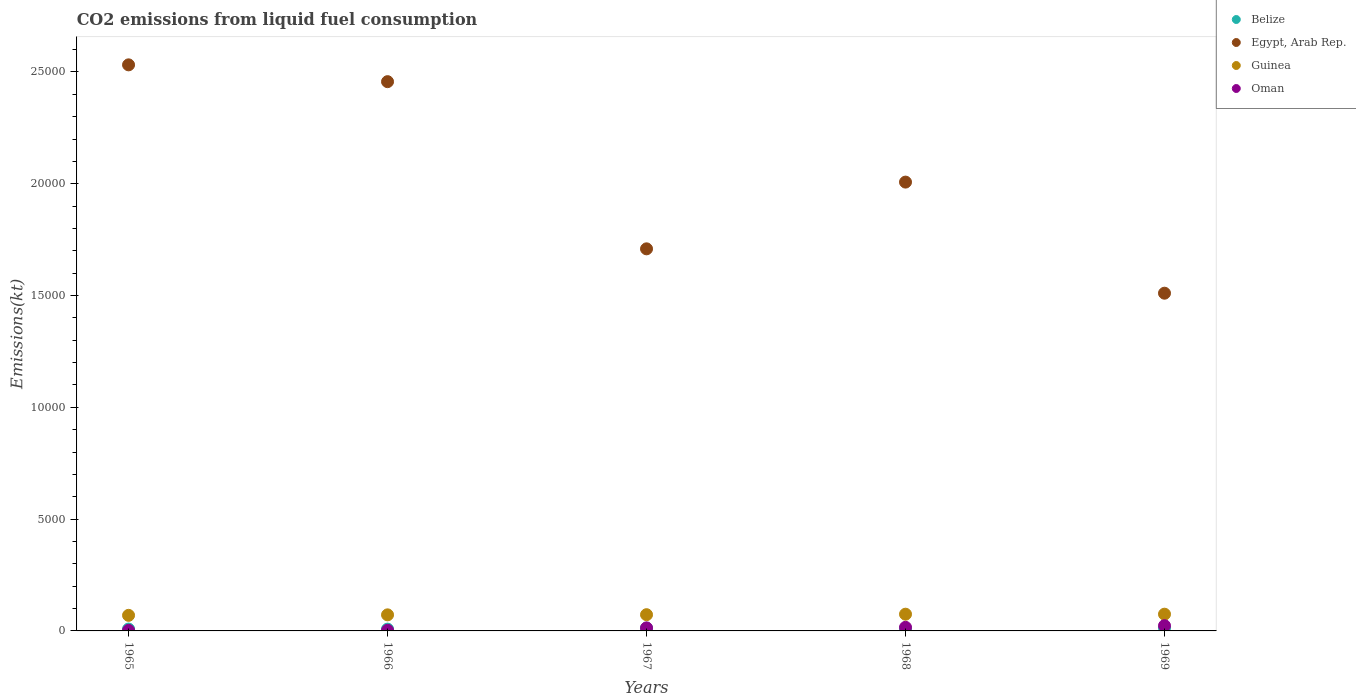Is the number of dotlines equal to the number of legend labels?
Keep it short and to the point. Yes. What is the amount of CO2 emitted in Belize in 1966?
Keep it short and to the point. 80.67. Across all years, what is the maximum amount of CO2 emitted in Oman?
Ensure brevity in your answer.  234.69. Across all years, what is the minimum amount of CO2 emitted in Guinea?
Make the answer very short. 696.73. In which year was the amount of CO2 emitted in Belize maximum?
Keep it short and to the point. 1969. In which year was the amount of CO2 emitted in Oman minimum?
Make the answer very short. 1965. What is the total amount of CO2 emitted in Oman in the graph?
Give a very brief answer. 586.72. What is the difference between the amount of CO2 emitted in Egypt, Arab Rep. in 1966 and that in 1969?
Provide a short and direct response. 9460.86. What is the difference between the amount of CO2 emitted in Belize in 1966 and the amount of CO2 emitted in Guinea in 1969?
Ensure brevity in your answer.  -667.39. What is the average amount of CO2 emitted in Guinea per year?
Provide a succinct answer. 727.53. In the year 1966, what is the difference between the amount of CO2 emitted in Guinea and amount of CO2 emitted in Belize?
Provide a short and direct response. 638.06. What is the ratio of the amount of CO2 emitted in Belize in 1967 to that in 1968?
Keep it short and to the point. 1.18. Is the difference between the amount of CO2 emitted in Guinea in 1967 and 1969 greater than the difference between the amount of CO2 emitted in Belize in 1967 and 1969?
Give a very brief answer. No. What is the difference between the highest and the second highest amount of CO2 emitted in Belize?
Ensure brevity in your answer.  14.67. What is the difference between the highest and the lowest amount of CO2 emitted in Oman?
Your answer should be very brief. 209.02. In how many years, is the amount of CO2 emitted in Oman greater than the average amount of CO2 emitted in Oman taken over all years?
Your answer should be compact. 3. Is it the case that in every year, the sum of the amount of CO2 emitted in Oman and amount of CO2 emitted in Guinea  is greater than the sum of amount of CO2 emitted in Egypt, Arab Rep. and amount of CO2 emitted in Belize?
Provide a short and direct response. Yes. Is it the case that in every year, the sum of the amount of CO2 emitted in Oman and amount of CO2 emitted in Egypt, Arab Rep.  is greater than the amount of CO2 emitted in Guinea?
Offer a very short reply. Yes. Does the amount of CO2 emitted in Egypt, Arab Rep. monotonically increase over the years?
Your answer should be compact. No. Is the amount of CO2 emitted in Belize strictly greater than the amount of CO2 emitted in Egypt, Arab Rep. over the years?
Offer a terse response. No. Is the amount of CO2 emitted in Belize strictly less than the amount of CO2 emitted in Egypt, Arab Rep. over the years?
Make the answer very short. Yes. How many dotlines are there?
Offer a terse response. 4. How many years are there in the graph?
Make the answer very short. 5. Are the values on the major ticks of Y-axis written in scientific E-notation?
Make the answer very short. No. Does the graph contain any zero values?
Keep it short and to the point. No. Does the graph contain grids?
Provide a short and direct response. No. Where does the legend appear in the graph?
Your answer should be very brief. Top right. How are the legend labels stacked?
Your answer should be compact. Vertical. What is the title of the graph?
Provide a short and direct response. CO2 emissions from liquid fuel consumption. What is the label or title of the X-axis?
Provide a succinct answer. Years. What is the label or title of the Y-axis?
Offer a very short reply. Emissions(kt). What is the Emissions(kt) of Belize in 1965?
Make the answer very short. 84.34. What is the Emissions(kt) of Egypt, Arab Rep. in 1965?
Make the answer very short. 2.53e+04. What is the Emissions(kt) in Guinea in 1965?
Your answer should be very brief. 696.73. What is the Emissions(kt) of Oman in 1965?
Make the answer very short. 25.67. What is the Emissions(kt) of Belize in 1966?
Your answer should be compact. 80.67. What is the Emissions(kt) of Egypt, Arab Rep. in 1966?
Ensure brevity in your answer.  2.46e+04. What is the Emissions(kt) in Guinea in 1966?
Give a very brief answer. 718.73. What is the Emissions(kt) of Oman in 1966?
Provide a succinct answer. 29.34. What is the Emissions(kt) in Belize in 1967?
Give a very brief answer. 121.01. What is the Emissions(kt) in Egypt, Arab Rep. in 1967?
Provide a short and direct response. 1.71e+04. What is the Emissions(kt) in Guinea in 1967?
Provide a succinct answer. 726.07. What is the Emissions(kt) of Oman in 1967?
Your answer should be compact. 135.68. What is the Emissions(kt) of Belize in 1968?
Offer a terse response. 102.68. What is the Emissions(kt) of Egypt, Arab Rep. in 1968?
Offer a terse response. 2.01e+04. What is the Emissions(kt) in Guinea in 1968?
Your response must be concise. 748.07. What is the Emissions(kt) in Oman in 1968?
Offer a terse response. 161.35. What is the Emissions(kt) of Belize in 1969?
Ensure brevity in your answer.  135.68. What is the Emissions(kt) in Egypt, Arab Rep. in 1969?
Your answer should be compact. 1.51e+04. What is the Emissions(kt) in Guinea in 1969?
Provide a short and direct response. 748.07. What is the Emissions(kt) of Oman in 1969?
Your answer should be very brief. 234.69. Across all years, what is the maximum Emissions(kt) of Belize?
Your answer should be very brief. 135.68. Across all years, what is the maximum Emissions(kt) in Egypt, Arab Rep.?
Offer a very short reply. 2.53e+04. Across all years, what is the maximum Emissions(kt) in Guinea?
Ensure brevity in your answer.  748.07. Across all years, what is the maximum Emissions(kt) of Oman?
Ensure brevity in your answer.  234.69. Across all years, what is the minimum Emissions(kt) in Belize?
Your answer should be very brief. 80.67. Across all years, what is the minimum Emissions(kt) in Egypt, Arab Rep.?
Your answer should be very brief. 1.51e+04. Across all years, what is the minimum Emissions(kt) of Guinea?
Ensure brevity in your answer.  696.73. Across all years, what is the minimum Emissions(kt) of Oman?
Give a very brief answer. 25.67. What is the total Emissions(kt) of Belize in the graph?
Offer a terse response. 524.38. What is the total Emissions(kt) in Egypt, Arab Rep. in the graph?
Offer a very short reply. 1.02e+05. What is the total Emissions(kt) in Guinea in the graph?
Your response must be concise. 3637.66. What is the total Emissions(kt) in Oman in the graph?
Your answer should be very brief. 586.72. What is the difference between the Emissions(kt) of Belize in 1965 and that in 1966?
Provide a short and direct response. 3.67. What is the difference between the Emissions(kt) of Egypt, Arab Rep. in 1965 and that in 1966?
Keep it short and to the point. 751.74. What is the difference between the Emissions(kt) of Guinea in 1965 and that in 1966?
Give a very brief answer. -22. What is the difference between the Emissions(kt) of Oman in 1965 and that in 1966?
Ensure brevity in your answer.  -3.67. What is the difference between the Emissions(kt) of Belize in 1965 and that in 1967?
Your response must be concise. -36.67. What is the difference between the Emissions(kt) in Egypt, Arab Rep. in 1965 and that in 1967?
Your response must be concise. 8228.75. What is the difference between the Emissions(kt) in Guinea in 1965 and that in 1967?
Provide a succinct answer. -29.34. What is the difference between the Emissions(kt) of Oman in 1965 and that in 1967?
Give a very brief answer. -110.01. What is the difference between the Emissions(kt) in Belize in 1965 and that in 1968?
Give a very brief answer. -18.34. What is the difference between the Emissions(kt) in Egypt, Arab Rep. in 1965 and that in 1968?
Provide a short and direct response. 5243.81. What is the difference between the Emissions(kt) of Guinea in 1965 and that in 1968?
Ensure brevity in your answer.  -51.34. What is the difference between the Emissions(kt) in Oman in 1965 and that in 1968?
Give a very brief answer. -135.68. What is the difference between the Emissions(kt) of Belize in 1965 and that in 1969?
Offer a very short reply. -51.34. What is the difference between the Emissions(kt) in Egypt, Arab Rep. in 1965 and that in 1969?
Your response must be concise. 1.02e+04. What is the difference between the Emissions(kt) in Guinea in 1965 and that in 1969?
Keep it short and to the point. -51.34. What is the difference between the Emissions(kt) of Oman in 1965 and that in 1969?
Offer a very short reply. -209.02. What is the difference between the Emissions(kt) of Belize in 1966 and that in 1967?
Your answer should be very brief. -40.34. What is the difference between the Emissions(kt) of Egypt, Arab Rep. in 1966 and that in 1967?
Offer a very short reply. 7477.01. What is the difference between the Emissions(kt) in Guinea in 1966 and that in 1967?
Give a very brief answer. -7.33. What is the difference between the Emissions(kt) in Oman in 1966 and that in 1967?
Offer a terse response. -106.34. What is the difference between the Emissions(kt) of Belize in 1966 and that in 1968?
Make the answer very short. -22. What is the difference between the Emissions(kt) in Egypt, Arab Rep. in 1966 and that in 1968?
Keep it short and to the point. 4492.07. What is the difference between the Emissions(kt) of Guinea in 1966 and that in 1968?
Provide a succinct answer. -29.34. What is the difference between the Emissions(kt) of Oman in 1966 and that in 1968?
Provide a succinct answer. -132.01. What is the difference between the Emissions(kt) of Belize in 1966 and that in 1969?
Offer a terse response. -55.01. What is the difference between the Emissions(kt) of Egypt, Arab Rep. in 1966 and that in 1969?
Your response must be concise. 9460.86. What is the difference between the Emissions(kt) in Guinea in 1966 and that in 1969?
Give a very brief answer. -29.34. What is the difference between the Emissions(kt) of Oman in 1966 and that in 1969?
Give a very brief answer. -205.35. What is the difference between the Emissions(kt) in Belize in 1967 and that in 1968?
Offer a very short reply. 18.34. What is the difference between the Emissions(kt) of Egypt, Arab Rep. in 1967 and that in 1968?
Keep it short and to the point. -2984.94. What is the difference between the Emissions(kt) in Guinea in 1967 and that in 1968?
Your response must be concise. -22. What is the difference between the Emissions(kt) in Oman in 1967 and that in 1968?
Give a very brief answer. -25.67. What is the difference between the Emissions(kt) in Belize in 1967 and that in 1969?
Provide a succinct answer. -14.67. What is the difference between the Emissions(kt) of Egypt, Arab Rep. in 1967 and that in 1969?
Offer a terse response. 1983.85. What is the difference between the Emissions(kt) in Guinea in 1967 and that in 1969?
Your answer should be compact. -22. What is the difference between the Emissions(kt) of Oman in 1967 and that in 1969?
Give a very brief answer. -99.01. What is the difference between the Emissions(kt) in Belize in 1968 and that in 1969?
Give a very brief answer. -33. What is the difference between the Emissions(kt) in Egypt, Arab Rep. in 1968 and that in 1969?
Give a very brief answer. 4968.78. What is the difference between the Emissions(kt) of Oman in 1968 and that in 1969?
Your answer should be compact. -73.34. What is the difference between the Emissions(kt) in Belize in 1965 and the Emissions(kt) in Egypt, Arab Rep. in 1966?
Your answer should be compact. -2.45e+04. What is the difference between the Emissions(kt) of Belize in 1965 and the Emissions(kt) of Guinea in 1966?
Keep it short and to the point. -634.39. What is the difference between the Emissions(kt) of Belize in 1965 and the Emissions(kt) of Oman in 1966?
Offer a terse response. 55.01. What is the difference between the Emissions(kt) of Egypt, Arab Rep. in 1965 and the Emissions(kt) of Guinea in 1966?
Your response must be concise. 2.46e+04. What is the difference between the Emissions(kt) of Egypt, Arab Rep. in 1965 and the Emissions(kt) of Oman in 1966?
Ensure brevity in your answer.  2.53e+04. What is the difference between the Emissions(kt) in Guinea in 1965 and the Emissions(kt) in Oman in 1966?
Offer a terse response. 667.39. What is the difference between the Emissions(kt) in Belize in 1965 and the Emissions(kt) in Egypt, Arab Rep. in 1967?
Your answer should be very brief. -1.70e+04. What is the difference between the Emissions(kt) in Belize in 1965 and the Emissions(kt) in Guinea in 1967?
Give a very brief answer. -641.73. What is the difference between the Emissions(kt) in Belize in 1965 and the Emissions(kt) in Oman in 1967?
Ensure brevity in your answer.  -51.34. What is the difference between the Emissions(kt) in Egypt, Arab Rep. in 1965 and the Emissions(kt) in Guinea in 1967?
Offer a terse response. 2.46e+04. What is the difference between the Emissions(kt) of Egypt, Arab Rep. in 1965 and the Emissions(kt) of Oman in 1967?
Make the answer very short. 2.52e+04. What is the difference between the Emissions(kt) of Guinea in 1965 and the Emissions(kt) of Oman in 1967?
Give a very brief answer. 561.05. What is the difference between the Emissions(kt) in Belize in 1965 and the Emissions(kt) in Egypt, Arab Rep. in 1968?
Provide a succinct answer. -2.00e+04. What is the difference between the Emissions(kt) of Belize in 1965 and the Emissions(kt) of Guinea in 1968?
Make the answer very short. -663.73. What is the difference between the Emissions(kt) in Belize in 1965 and the Emissions(kt) in Oman in 1968?
Provide a short and direct response. -77.01. What is the difference between the Emissions(kt) of Egypt, Arab Rep. in 1965 and the Emissions(kt) of Guinea in 1968?
Offer a very short reply. 2.46e+04. What is the difference between the Emissions(kt) in Egypt, Arab Rep. in 1965 and the Emissions(kt) in Oman in 1968?
Your answer should be compact. 2.52e+04. What is the difference between the Emissions(kt) in Guinea in 1965 and the Emissions(kt) in Oman in 1968?
Provide a short and direct response. 535.38. What is the difference between the Emissions(kt) of Belize in 1965 and the Emissions(kt) of Egypt, Arab Rep. in 1969?
Provide a short and direct response. -1.50e+04. What is the difference between the Emissions(kt) in Belize in 1965 and the Emissions(kt) in Guinea in 1969?
Offer a very short reply. -663.73. What is the difference between the Emissions(kt) in Belize in 1965 and the Emissions(kt) in Oman in 1969?
Make the answer very short. -150.35. What is the difference between the Emissions(kt) in Egypt, Arab Rep. in 1965 and the Emissions(kt) in Guinea in 1969?
Provide a succinct answer. 2.46e+04. What is the difference between the Emissions(kt) in Egypt, Arab Rep. in 1965 and the Emissions(kt) in Oman in 1969?
Provide a short and direct response. 2.51e+04. What is the difference between the Emissions(kt) in Guinea in 1965 and the Emissions(kt) in Oman in 1969?
Your answer should be very brief. 462.04. What is the difference between the Emissions(kt) of Belize in 1966 and the Emissions(kt) of Egypt, Arab Rep. in 1967?
Give a very brief answer. -1.70e+04. What is the difference between the Emissions(kt) of Belize in 1966 and the Emissions(kt) of Guinea in 1967?
Keep it short and to the point. -645.39. What is the difference between the Emissions(kt) in Belize in 1966 and the Emissions(kt) in Oman in 1967?
Your answer should be very brief. -55.01. What is the difference between the Emissions(kt) of Egypt, Arab Rep. in 1966 and the Emissions(kt) of Guinea in 1967?
Your answer should be compact. 2.38e+04. What is the difference between the Emissions(kt) in Egypt, Arab Rep. in 1966 and the Emissions(kt) in Oman in 1967?
Provide a succinct answer. 2.44e+04. What is the difference between the Emissions(kt) of Guinea in 1966 and the Emissions(kt) of Oman in 1967?
Offer a terse response. 583.05. What is the difference between the Emissions(kt) in Belize in 1966 and the Emissions(kt) in Egypt, Arab Rep. in 1968?
Offer a very short reply. -2.00e+04. What is the difference between the Emissions(kt) of Belize in 1966 and the Emissions(kt) of Guinea in 1968?
Give a very brief answer. -667.39. What is the difference between the Emissions(kt) of Belize in 1966 and the Emissions(kt) of Oman in 1968?
Your answer should be compact. -80.67. What is the difference between the Emissions(kt) in Egypt, Arab Rep. in 1966 and the Emissions(kt) in Guinea in 1968?
Offer a very short reply. 2.38e+04. What is the difference between the Emissions(kt) in Egypt, Arab Rep. in 1966 and the Emissions(kt) in Oman in 1968?
Your answer should be very brief. 2.44e+04. What is the difference between the Emissions(kt) in Guinea in 1966 and the Emissions(kt) in Oman in 1968?
Keep it short and to the point. 557.38. What is the difference between the Emissions(kt) of Belize in 1966 and the Emissions(kt) of Egypt, Arab Rep. in 1969?
Your response must be concise. -1.50e+04. What is the difference between the Emissions(kt) of Belize in 1966 and the Emissions(kt) of Guinea in 1969?
Ensure brevity in your answer.  -667.39. What is the difference between the Emissions(kt) in Belize in 1966 and the Emissions(kt) in Oman in 1969?
Give a very brief answer. -154.01. What is the difference between the Emissions(kt) of Egypt, Arab Rep. in 1966 and the Emissions(kt) of Guinea in 1969?
Provide a short and direct response. 2.38e+04. What is the difference between the Emissions(kt) in Egypt, Arab Rep. in 1966 and the Emissions(kt) in Oman in 1969?
Keep it short and to the point. 2.43e+04. What is the difference between the Emissions(kt) of Guinea in 1966 and the Emissions(kt) of Oman in 1969?
Make the answer very short. 484.04. What is the difference between the Emissions(kt) of Belize in 1967 and the Emissions(kt) of Egypt, Arab Rep. in 1968?
Your answer should be very brief. -2.00e+04. What is the difference between the Emissions(kt) in Belize in 1967 and the Emissions(kt) in Guinea in 1968?
Offer a terse response. -627.06. What is the difference between the Emissions(kt) of Belize in 1967 and the Emissions(kt) of Oman in 1968?
Offer a very short reply. -40.34. What is the difference between the Emissions(kt) in Egypt, Arab Rep. in 1967 and the Emissions(kt) in Guinea in 1968?
Offer a very short reply. 1.63e+04. What is the difference between the Emissions(kt) in Egypt, Arab Rep. in 1967 and the Emissions(kt) in Oman in 1968?
Offer a terse response. 1.69e+04. What is the difference between the Emissions(kt) of Guinea in 1967 and the Emissions(kt) of Oman in 1968?
Offer a very short reply. 564.72. What is the difference between the Emissions(kt) of Belize in 1967 and the Emissions(kt) of Egypt, Arab Rep. in 1969?
Your answer should be compact. -1.50e+04. What is the difference between the Emissions(kt) of Belize in 1967 and the Emissions(kt) of Guinea in 1969?
Ensure brevity in your answer.  -627.06. What is the difference between the Emissions(kt) in Belize in 1967 and the Emissions(kt) in Oman in 1969?
Your answer should be compact. -113.68. What is the difference between the Emissions(kt) of Egypt, Arab Rep. in 1967 and the Emissions(kt) of Guinea in 1969?
Provide a succinct answer. 1.63e+04. What is the difference between the Emissions(kt) in Egypt, Arab Rep. in 1967 and the Emissions(kt) in Oman in 1969?
Your answer should be very brief. 1.69e+04. What is the difference between the Emissions(kt) of Guinea in 1967 and the Emissions(kt) of Oman in 1969?
Offer a terse response. 491.38. What is the difference between the Emissions(kt) of Belize in 1968 and the Emissions(kt) of Egypt, Arab Rep. in 1969?
Provide a succinct answer. -1.50e+04. What is the difference between the Emissions(kt) of Belize in 1968 and the Emissions(kt) of Guinea in 1969?
Keep it short and to the point. -645.39. What is the difference between the Emissions(kt) of Belize in 1968 and the Emissions(kt) of Oman in 1969?
Give a very brief answer. -132.01. What is the difference between the Emissions(kt) in Egypt, Arab Rep. in 1968 and the Emissions(kt) in Guinea in 1969?
Offer a very short reply. 1.93e+04. What is the difference between the Emissions(kt) of Egypt, Arab Rep. in 1968 and the Emissions(kt) of Oman in 1969?
Ensure brevity in your answer.  1.98e+04. What is the difference between the Emissions(kt) of Guinea in 1968 and the Emissions(kt) of Oman in 1969?
Ensure brevity in your answer.  513.38. What is the average Emissions(kt) of Belize per year?
Offer a very short reply. 104.88. What is the average Emissions(kt) of Egypt, Arab Rep. per year?
Ensure brevity in your answer.  2.04e+04. What is the average Emissions(kt) in Guinea per year?
Provide a short and direct response. 727.53. What is the average Emissions(kt) of Oman per year?
Offer a terse response. 117.34. In the year 1965, what is the difference between the Emissions(kt) in Belize and Emissions(kt) in Egypt, Arab Rep.?
Offer a terse response. -2.52e+04. In the year 1965, what is the difference between the Emissions(kt) in Belize and Emissions(kt) in Guinea?
Provide a short and direct response. -612.39. In the year 1965, what is the difference between the Emissions(kt) in Belize and Emissions(kt) in Oman?
Your answer should be very brief. 58.67. In the year 1965, what is the difference between the Emissions(kt) in Egypt, Arab Rep. and Emissions(kt) in Guinea?
Make the answer very short. 2.46e+04. In the year 1965, what is the difference between the Emissions(kt) of Egypt, Arab Rep. and Emissions(kt) of Oman?
Offer a very short reply. 2.53e+04. In the year 1965, what is the difference between the Emissions(kt) in Guinea and Emissions(kt) in Oman?
Your response must be concise. 671.06. In the year 1966, what is the difference between the Emissions(kt) of Belize and Emissions(kt) of Egypt, Arab Rep.?
Your answer should be compact. -2.45e+04. In the year 1966, what is the difference between the Emissions(kt) of Belize and Emissions(kt) of Guinea?
Provide a short and direct response. -638.06. In the year 1966, what is the difference between the Emissions(kt) of Belize and Emissions(kt) of Oman?
Provide a short and direct response. 51.34. In the year 1966, what is the difference between the Emissions(kt) of Egypt, Arab Rep. and Emissions(kt) of Guinea?
Provide a succinct answer. 2.38e+04. In the year 1966, what is the difference between the Emissions(kt) in Egypt, Arab Rep. and Emissions(kt) in Oman?
Your answer should be compact. 2.45e+04. In the year 1966, what is the difference between the Emissions(kt) in Guinea and Emissions(kt) in Oman?
Your response must be concise. 689.4. In the year 1967, what is the difference between the Emissions(kt) in Belize and Emissions(kt) in Egypt, Arab Rep.?
Keep it short and to the point. -1.70e+04. In the year 1967, what is the difference between the Emissions(kt) of Belize and Emissions(kt) of Guinea?
Provide a short and direct response. -605.05. In the year 1967, what is the difference between the Emissions(kt) of Belize and Emissions(kt) of Oman?
Your answer should be compact. -14.67. In the year 1967, what is the difference between the Emissions(kt) in Egypt, Arab Rep. and Emissions(kt) in Guinea?
Ensure brevity in your answer.  1.64e+04. In the year 1967, what is the difference between the Emissions(kt) in Egypt, Arab Rep. and Emissions(kt) in Oman?
Make the answer very short. 1.70e+04. In the year 1967, what is the difference between the Emissions(kt) in Guinea and Emissions(kt) in Oman?
Offer a very short reply. 590.39. In the year 1968, what is the difference between the Emissions(kt) of Belize and Emissions(kt) of Egypt, Arab Rep.?
Provide a short and direct response. -2.00e+04. In the year 1968, what is the difference between the Emissions(kt) of Belize and Emissions(kt) of Guinea?
Make the answer very short. -645.39. In the year 1968, what is the difference between the Emissions(kt) in Belize and Emissions(kt) in Oman?
Give a very brief answer. -58.67. In the year 1968, what is the difference between the Emissions(kt) of Egypt, Arab Rep. and Emissions(kt) of Guinea?
Offer a terse response. 1.93e+04. In the year 1968, what is the difference between the Emissions(kt) in Egypt, Arab Rep. and Emissions(kt) in Oman?
Ensure brevity in your answer.  1.99e+04. In the year 1968, what is the difference between the Emissions(kt) in Guinea and Emissions(kt) in Oman?
Your response must be concise. 586.72. In the year 1969, what is the difference between the Emissions(kt) in Belize and Emissions(kt) in Egypt, Arab Rep.?
Offer a very short reply. -1.50e+04. In the year 1969, what is the difference between the Emissions(kt) of Belize and Emissions(kt) of Guinea?
Ensure brevity in your answer.  -612.39. In the year 1969, what is the difference between the Emissions(kt) in Belize and Emissions(kt) in Oman?
Provide a short and direct response. -99.01. In the year 1969, what is the difference between the Emissions(kt) of Egypt, Arab Rep. and Emissions(kt) of Guinea?
Provide a succinct answer. 1.44e+04. In the year 1969, what is the difference between the Emissions(kt) of Egypt, Arab Rep. and Emissions(kt) of Oman?
Your response must be concise. 1.49e+04. In the year 1969, what is the difference between the Emissions(kt) in Guinea and Emissions(kt) in Oman?
Your response must be concise. 513.38. What is the ratio of the Emissions(kt) in Belize in 1965 to that in 1966?
Offer a very short reply. 1.05. What is the ratio of the Emissions(kt) in Egypt, Arab Rep. in 1965 to that in 1966?
Your answer should be very brief. 1.03. What is the ratio of the Emissions(kt) of Guinea in 1965 to that in 1966?
Your answer should be very brief. 0.97. What is the ratio of the Emissions(kt) of Oman in 1965 to that in 1966?
Your response must be concise. 0.88. What is the ratio of the Emissions(kt) of Belize in 1965 to that in 1967?
Your response must be concise. 0.7. What is the ratio of the Emissions(kt) of Egypt, Arab Rep. in 1965 to that in 1967?
Your answer should be very brief. 1.48. What is the ratio of the Emissions(kt) of Guinea in 1965 to that in 1967?
Your answer should be compact. 0.96. What is the ratio of the Emissions(kt) of Oman in 1965 to that in 1967?
Ensure brevity in your answer.  0.19. What is the ratio of the Emissions(kt) of Belize in 1965 to that in 1968?
Offer a very short reply. 0.82. What is the ratio of the Emissions(kt) of Egypt, Arab Rep. in 1965 to that in 1968?
Provide a succinct answer. 1.26. What is the ratio of the Emissions(kt) of Guinea in 1965 to that in 1968?
Offer a terse response. 0.93. What is the ratio of the Emissions(kt) of Oman in 1965 to that in 1968?
Your answer should be compact. 0.16. What is the ratio of the Emissions(kt) of Belize in 1965 to that in 1969?
Give a very brief answer. 0.62. What is the ratio of the Emissions(kt) of Egypt, Arab Rep. in 1965 to that in 1969?
Make the answer very short. 1.68. What is the ratio of the Emissions(kt) in Guinea in 1965 to that in 1969?
Your answer should be compact. 0.93. What is the ratio of the Emissions(kt) of Oman in 1965 to that in 1969?
Make the answer very short. 0.11. What is the ratio of the Emissions(kt) in Belize in 1966 to that in 1967?
Offer a terse response. 0.67. What is the ratio of the Emissions(kt) in Egypt, Arab Rep. in 1966 to that in 1967?
Make the answer very short. 1.44. What is the ratio of the Emissions(kt) in Guinea in 1966 to that in 1967?
Offer a terse response. 0.99. What is the ratio of the Emissions(kt) in Oman in 1966 to that in 1967?
Ensure brevity in your answer.  0.22. What is the ratio of the Emissions(kt) of Belize in 1966 to that in 1968?
Your response must be concise. 0.79. What is the ratio of the Emissions(kt) in Egypt, Arab Rep. in 1966 to that in 1968?
Ensure brevity in your answer.  1.22. What is the ratio of the Emissions(kt) of Guinea in 1966 to that in 1968?
Your response must be concise. 0.96. What is the ratio of the Emissions(kt) of Oman in 1966 to that in 1968?
Your response must be concise. 0.18. What is the ratio of the Emissions(kt) of Belize in 1966 to that in 1969?
Make the answer very short. 0.59. What is the ratio of the Emissions(kt) in Egypt, Arab Rep. in 1966 to that in 1969?
Offer a very short reply. 1.63. What is the ratio of the Emissions(kt) in Guinea in 1966 to that in 1969?
Your response must be concise. 0.96. What is the ratio of the Emissions(kt) of Oman in 1966 to that in 1969?
Offer a very short reply. 0.12. What is the ratio of the Emissions(kt) of Belize in 1967 to that in 1968?
Offer a terse response. 1.18. What is the ratio of the Emissions(kt) of Egypt, Arab Rep. in 1967 to that in 1968?
Make the answer very short. 0.85. What is the ratio of the Emissions(kt) in Guinea in 1967 to that in 1968?
Provide a succinct answer. 0.97. What is the ratio of the Emissions(kt) in Oman in 1967 to that in 1968?
Make the answer very short. 0.84. What is the ratio of the Emissions(kt) of Belize in 1967 to that in 1969?
Offer a terse response. 0.89. What is the ratio of the Emissions(kt) in Egypt, Arab Rep. in 1967 to that in 1969?
Offer a very short reply. 1.13. What is the ratio of the Emissions(kt) of Guinea in 1967 to that in 1969?
Offer a very short reply. 0.97. What is the ratio of the Emissions(kt) in Oman in 1967 to that in 1969?
Provide a short and direct response. 0.58. What is the ratio of the Emissions(kt) of Belize in 1968 to that in 1969?
Give a very brief answer. 0.76. What is the ratio of the Emissions(kt) in Egypt, Arab Rep. in 1968 to that in 1969?
Keep it short and to the point. 1.33. What is the ratio of the Emissions(kt) in Guinea in 1968 to that in 1969?
Make the answer very short. 1. What is the ratio of the Emissions(kt) of Oman in 1968 to that in 1969?
Ensure brevity in your answer.  0.69. What is the difference between the highest and the second highest Emissions(kt) of Belize?
Your response must be concise. 14.67. What is the difference between the highest and the second highest Emissions(kt) of Egypt, Arab Rep.?
Your answer should be compact. 751.74. What is the difference between the highest and the second highest Emissions(kt) in Oman?
Offer a very short reply. 73.34. What is the difference between the highest and the lowest Emissions(kt) in Belize?
Give a very brief answer. 55.01. What is the difference between the highest and the lowest Emissions(kt) of Egypt, Arab Rep.?
Keep it short and to the point. 1.02e+04. What is the difference between the highest and the lowest Emissions(kt) of Guinea?
Your response must be concise. 51.34. What is the difference between the highest and the lowest Emissions(kt) in Oman?
Your response must be concise. 209.02. 